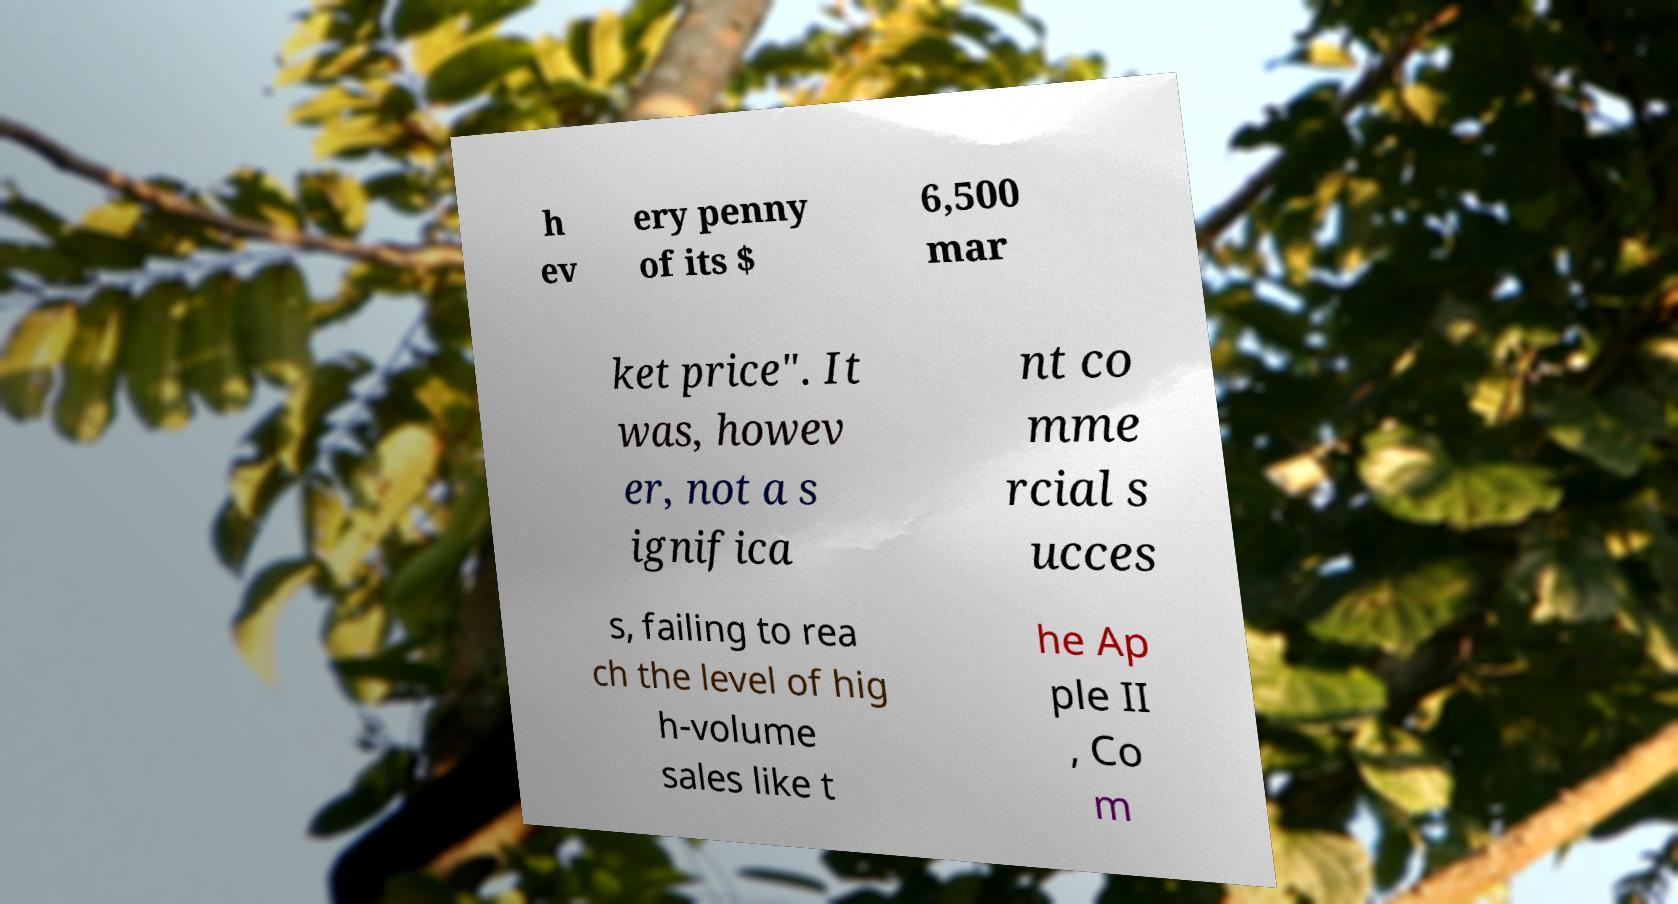For documentation purposes, I need the text within this image transcribed. Could you provide that? h ev ery penny of its $ 6,500 mar ket price". It was, howev er, not a s ignifica nt co mme rcial s ucces s, failing to rea ch the level of hig h-volume sales like t he Ap ple II , Co m 